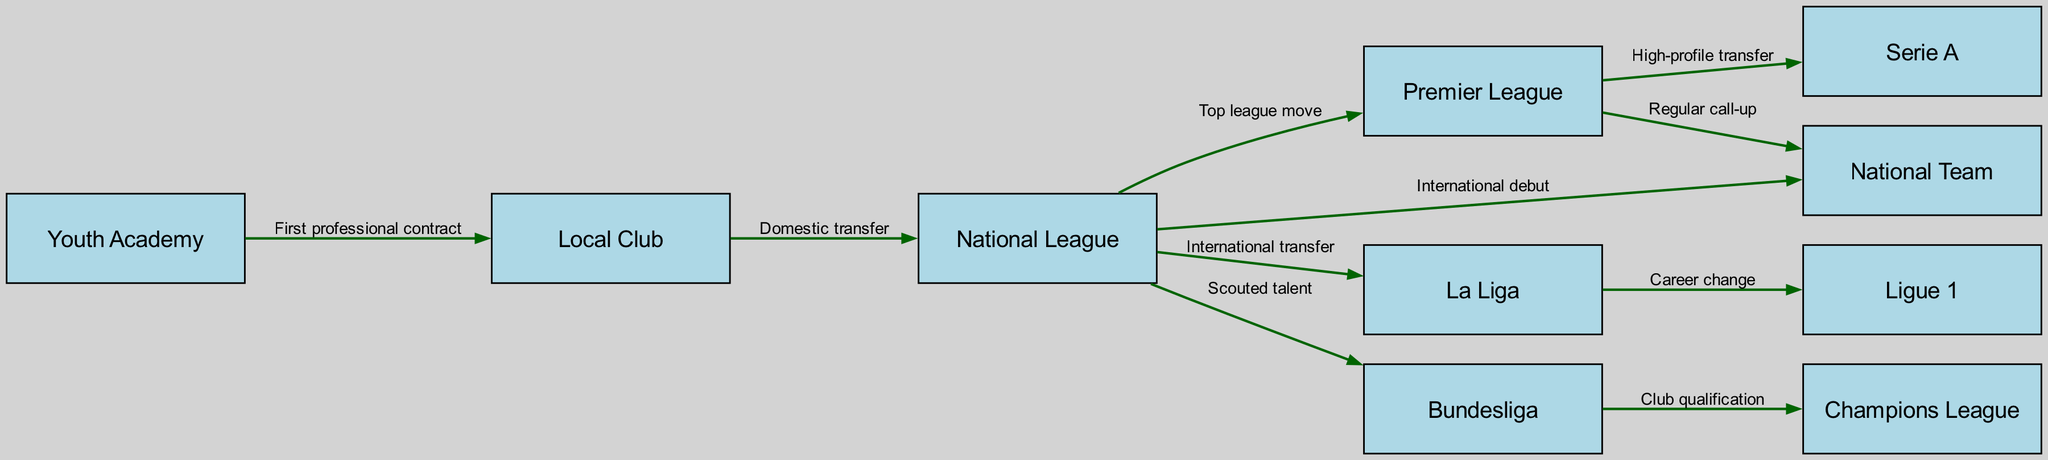What is the starting point for young football talents in their career progression? The diagram shows that the starting point is the "Youth Academy," which is where young players often begin their professional journey.
Answer: Youth Academy How many total nodes are present in the diagram? By counting all the nodes listed in the diagram, we find there are ten distinct nodes representing different career stages and leagues.
Answer: 10 Which league transition connects the National League to the Premier League? According to the diagram, the connection is marked as a "Top league move" which indicates the transition from the National League to the Premier League.
Answer: Top league move What is the relationship between the National League and the National Team? The diagram indicates that the connection is an "International debut," showing how a player can progress from the National League to representing their country.
Answer: International debut From which league can a player move to Ligue 1? The diagram states that a player can move to Ligue 1 from La Liga, and this transition is labeled as "Career change."
Answer: La Liga Which league is directly connected to the Champions League? The diagram specifies that the Bundesliga is directly connected to the Champions League through a relationship labeled "Club qualification."
Answer: Bundesliga What kind of transfer leads a player from Premier League to Serie A? The transition from Premier League to Serie A is described as a "High-profile transfer," indicating a significant move for players.
Answer: High-profile transfer How does a player advance from Bundesliga to the National Team? The diagram does not show a direct relationship but indicates that a player can advance to the National Team through various potential steps; however, the primary edge relevant is "International debut" from the National League.
Answer: N/A How is a club in the National League associated with a player's international debut? The connection between the National League and National Team is established through the edge labeled "International debut," indicating that performance in the National League can lead to national representation.
Answer: International debut What is the first transfer step for a player coming from the Youth Academy? The first step for a player coming from the Youth Academy is signing their "First professional contract" with a Local Club, according to the diagram.
Answer: First professional contract 